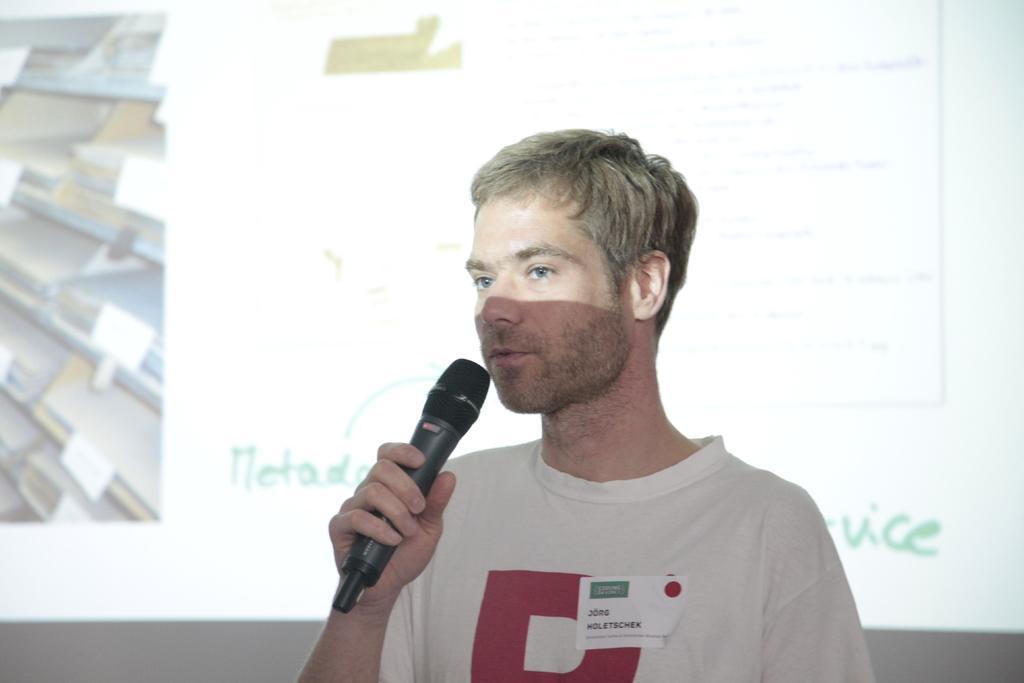Describe this image in one or two sentences. In this image there is a man standing and holding a mic at the background we can the screen. 